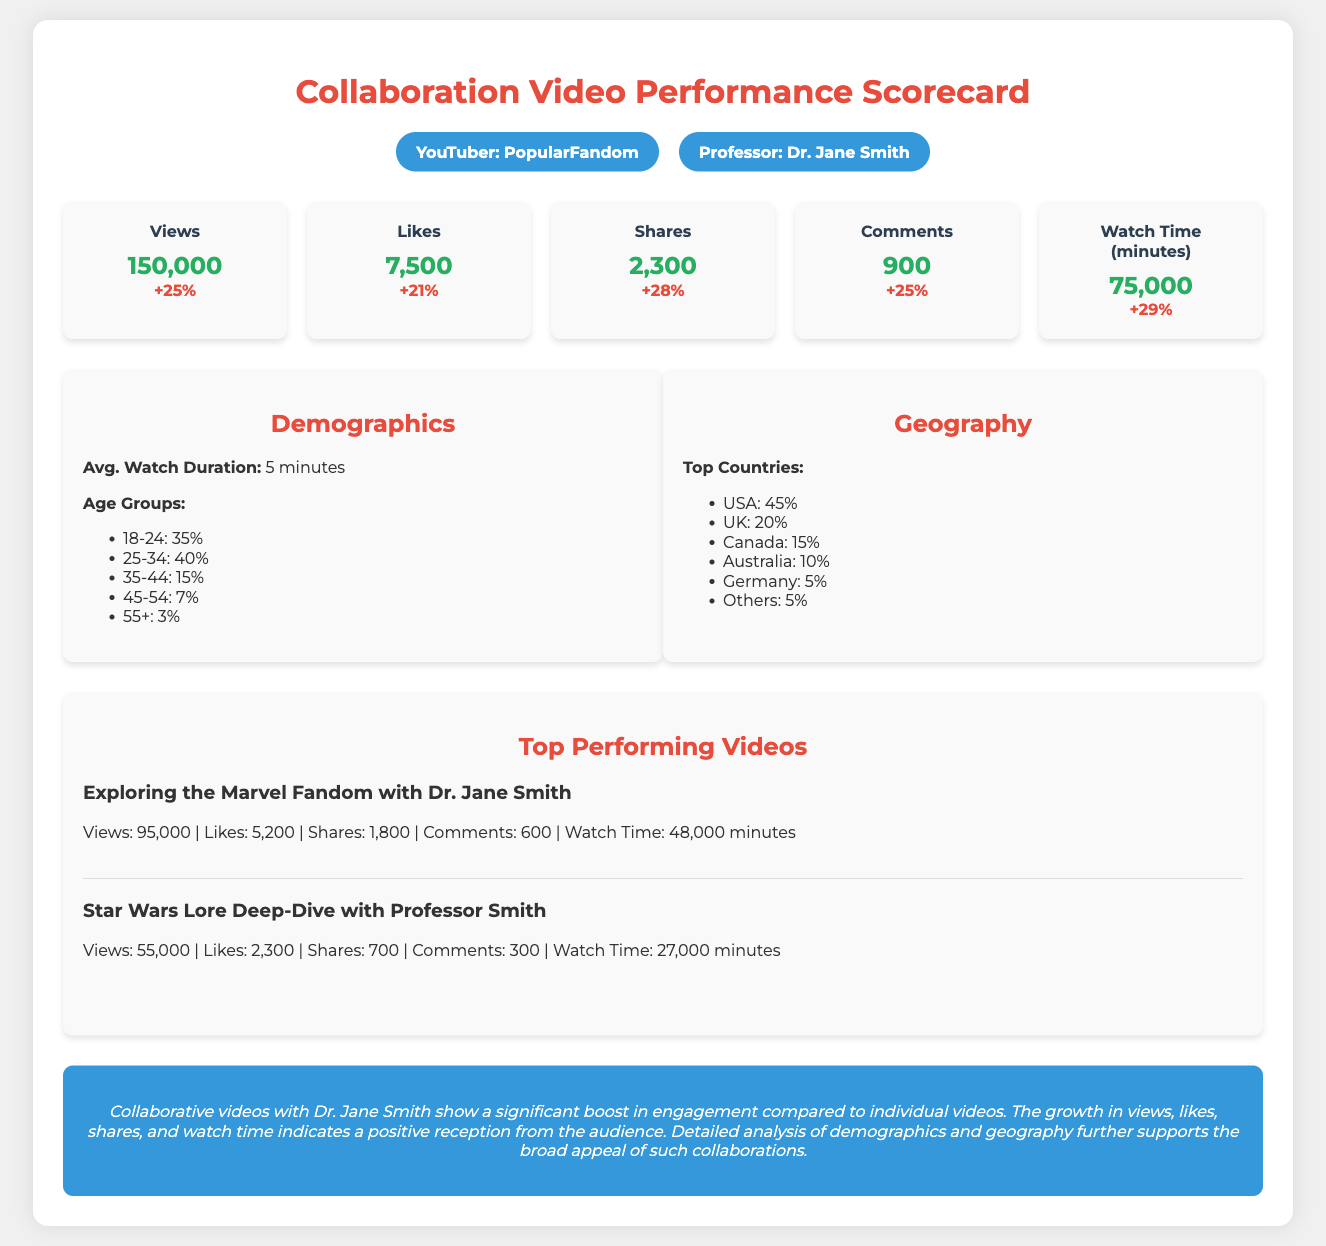What is the total number of views? The total number of views reported in the scorecard is explicitly listed as 150,000.
Answer: 150,000 How many likes did the collaboration video receive? The number of likes for the collaboration video is clearly mentioned as 7,500 in the document.
Answer: 7,500 What percentage growth in shares was observed? The percentage growth for shares is detailed in the document, which states a growth of 28%.
Answer: 28% What is the average watch duration? The average watch duration is highlighted in the demographics section as 5 minutes.
Answer: 5 minutes Which age group has the highest percentage of viewers? The age group with the highest percentage of viewers is specified in the document as 25-34 with 40%.
Answer: 25-34 Which country has the highest viewer percentage? The country with the highest viewer percentage is indicated in the geography section as the USA with 45%.
Answer: USA What was the watch time in minutes? The total watch time in minutes for the collaboration video is given as 75,000 minutes in the scorecard.
Answer: 75,000 minutes Which video performed the best in terms of views? The document provides the title of the video with the highest views, which is "Exploring the Marvel Fandom with Dr. Jane Smith".
Answer: Exploring the Marvel Fandom with Dr. Jane Smith What is the purpose of this scorecard? The scorecard serves as a comprehensive breakdown of key performance indicators for collaborative videos with Dr. Jane Smith.
Answer: To analyze collaborative video performance 